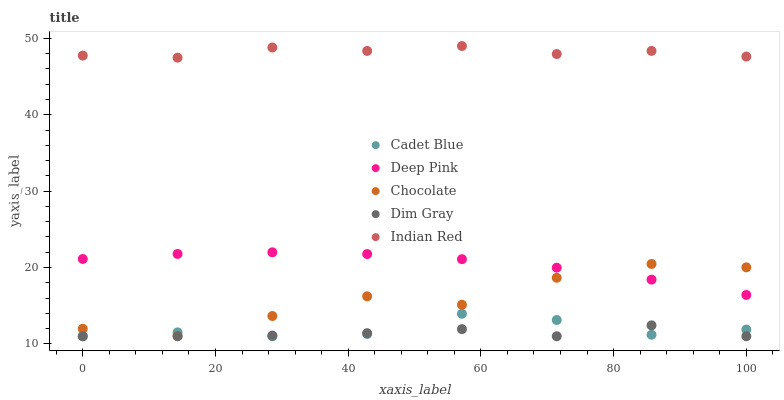Does Dim Gray have the minimum area under the curve?
Answer yes or no. Yes. Does Indian Red have the maximum area under the curve?
Answer yes or no. Yes. Does Cadet Blue have the minimum area under the curve?
Answer yes or no. No. Does Cadet Blue have the maximum area under the curve?
Answer yes or no. No. Is Deep Pink the smoothest?
Answer yes or no. Yes. Is Chocolate the roughest?
Answer yes or no. Yes. Is Cadet Blue the smoothest?
Answer yes or no. No. Is Cadet Blue the roughest?
Answer yes or no. No. Does Dim Gray have the lowest value?
Answer yes or no. Yes. Does Indian Red have the lowest value?
Answer yes or no. No. Does Indian Red have the highest value?
Answer yes or no. Yes. Does Cadet Blue have the highest value?
Answer yes or no. No. Is Dim Gray less than Indian Red?
Answer yes or no. Yes. Is Deep Pink greater than Dim Gray?
Answer yes or no. Yes. Does Dim Gray intersect Cadet Blue?
Answer yes or no. Yes. Is Dim Gray less than Cadet Blue?
Answer yes or no. No. Is Dim Gray greater than Cadet Blue?
Answer yes or no. No. Does Dim Gray intersect Indian Red?
Answer yes or no. No. 